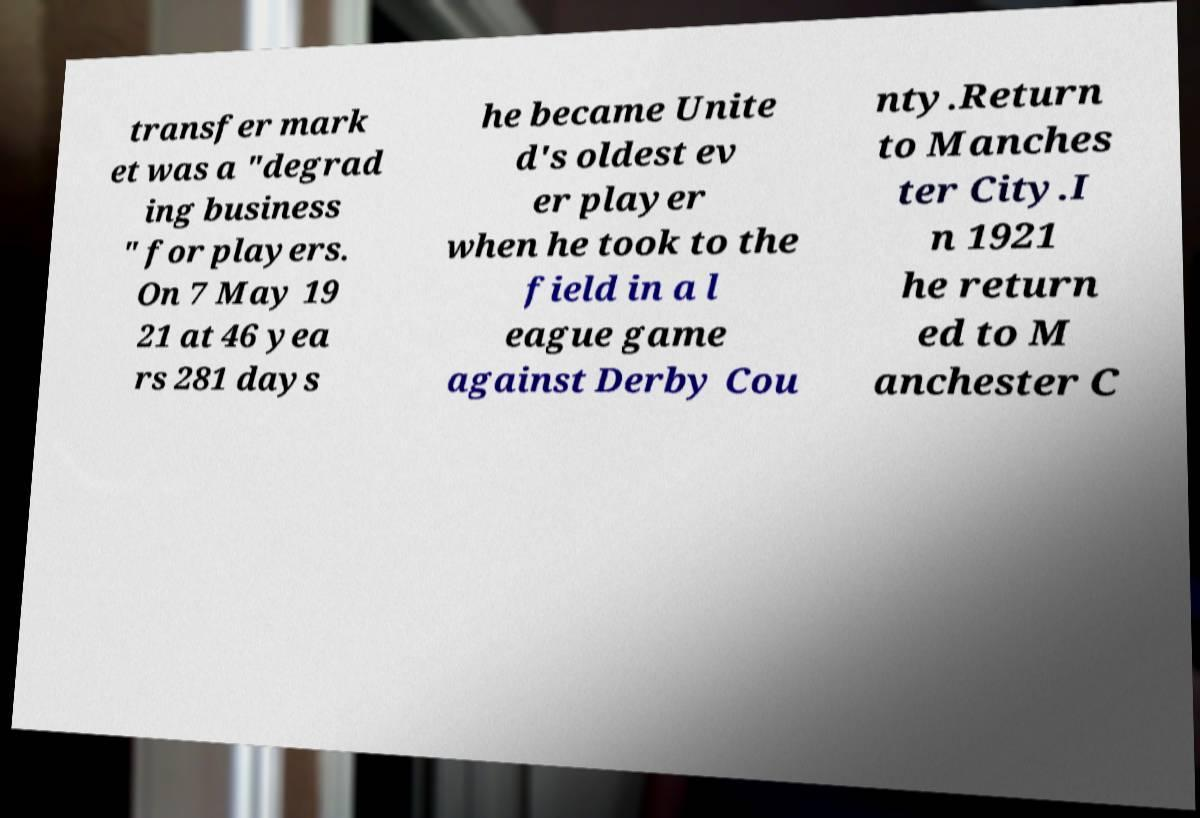There's text embedded in this image that I need extracted. Can you transcribe it verbatim? transfer mark et was a "degrad ing business " for players. On 7 May 19 21 at 46 yea rs 281 days he became Unite d's oldest ev er player when he took to the field in a l eague game against Derby Cou nty.Return to Manches ter City.I n 1921 he return ed to M anchester C 